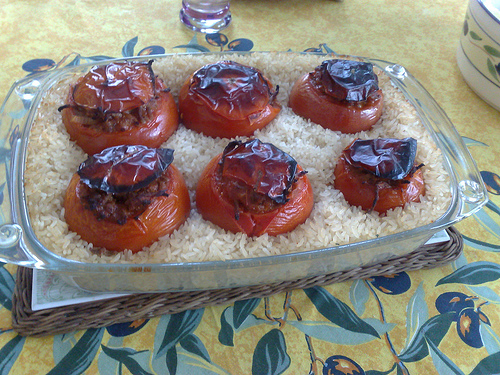<image>
Is the tomato above the rice? No. The tomato is not positioned above the rice. The vertical arrangement shows a different relationship. Where is the tomato in relation to the table? Is it on the table? Yes. Looking at the image, I can see the tomato is positioned on top of the table, with the table providing support. 